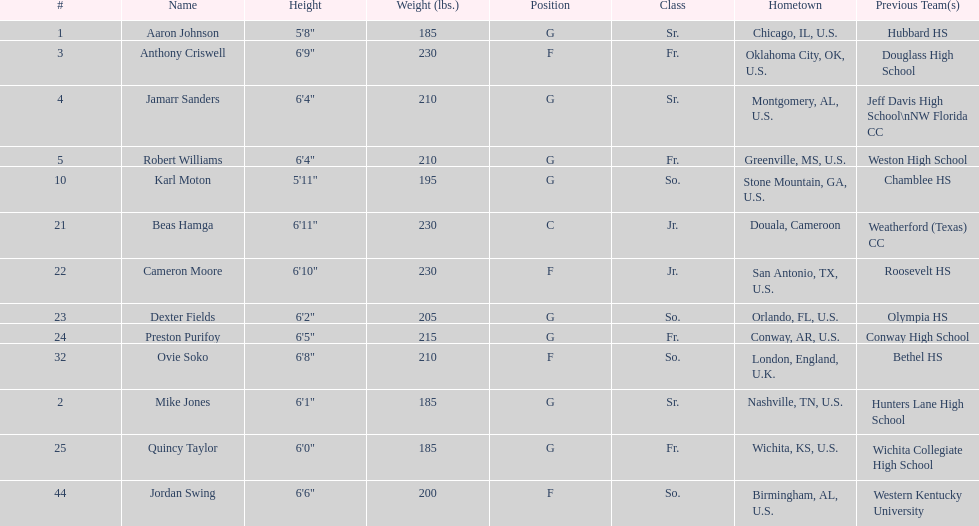Who are all the participating players? Aaron Johnson, Anthony Criswell, Jamarr Sanders, Robert Williams, Karl Moton, Beas Hamga, Cameron Moore, Dexter Fields, Preston Purifoy, Ovie Soko, Mike Jones, Quincy Taylor, Jordan Swing. Which of them are not from the u.s.? Beas Hamga, Ovie Soko. Apart from soko, who are the other non-american players? Beas Hamga. 